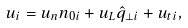<formula> <loc_0><loc_0><loc_500><loc_500>u _ { i } = u _ { n } n _ { 0 i } + u _ { L } { \hat { q } } _ { \perp i } + u _ { t i } ,</formula> 